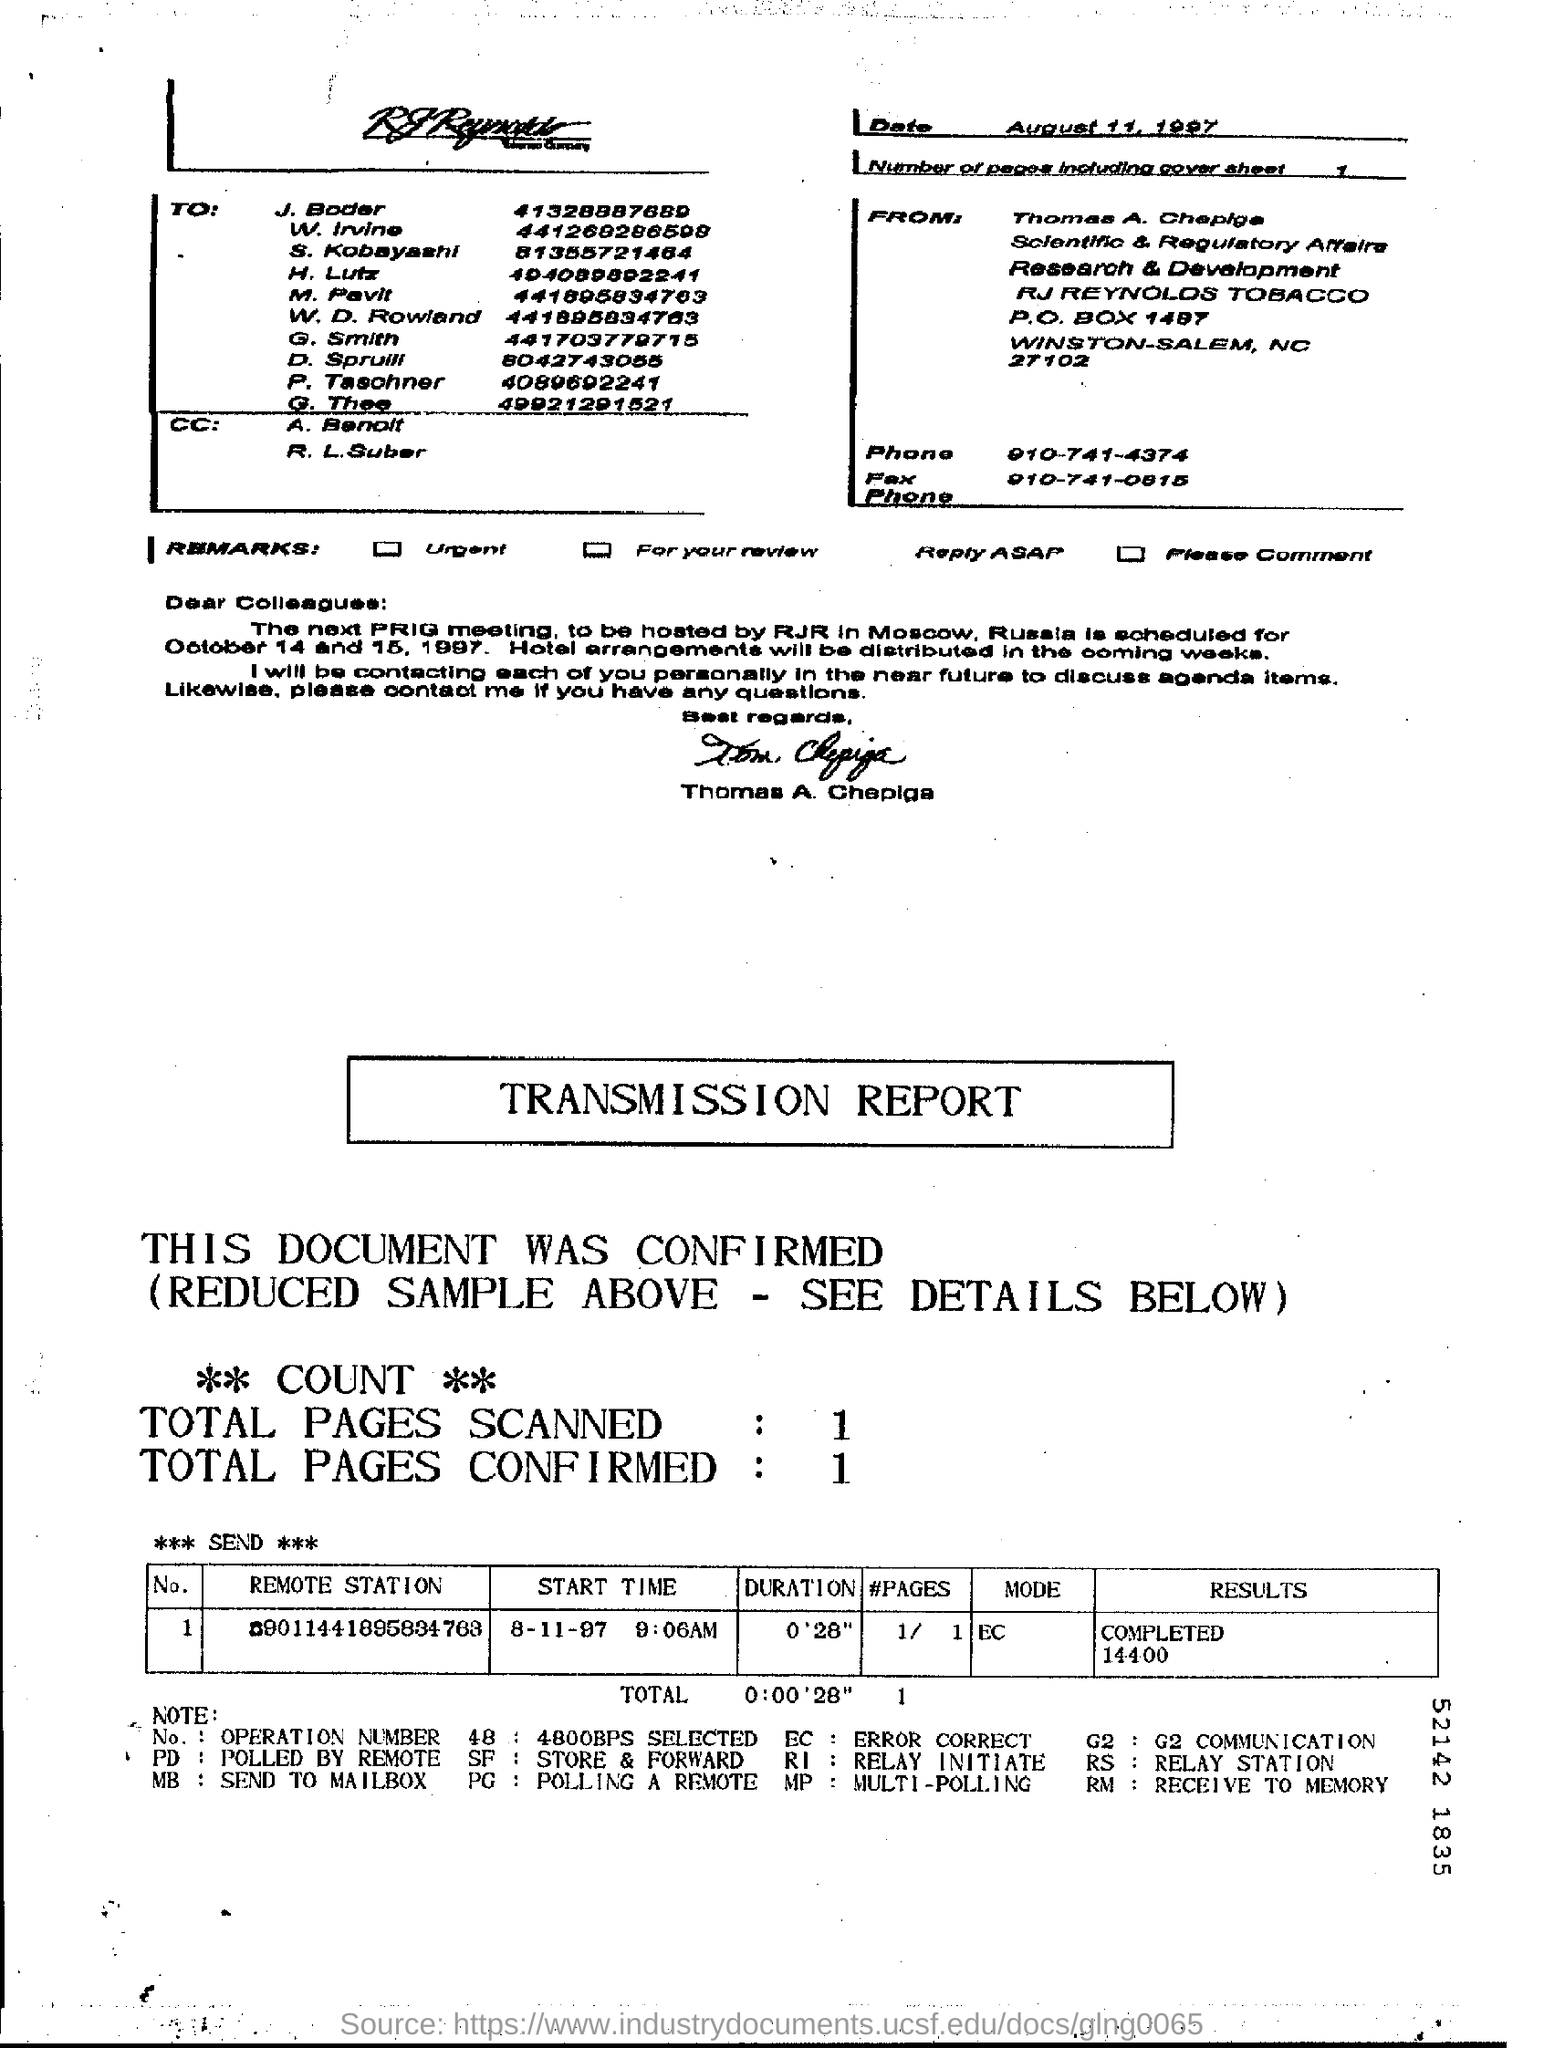What is the "Start Time"?
Make the answer very short. 8-11-97 9:06AM. What is the "Duration"?
Your response must be concise. 0'28". What are the Total Pages Scanned?
Offer a terse response. 1. What are the Total Pages Confirmed?
Provide a succinct answer. 1. 